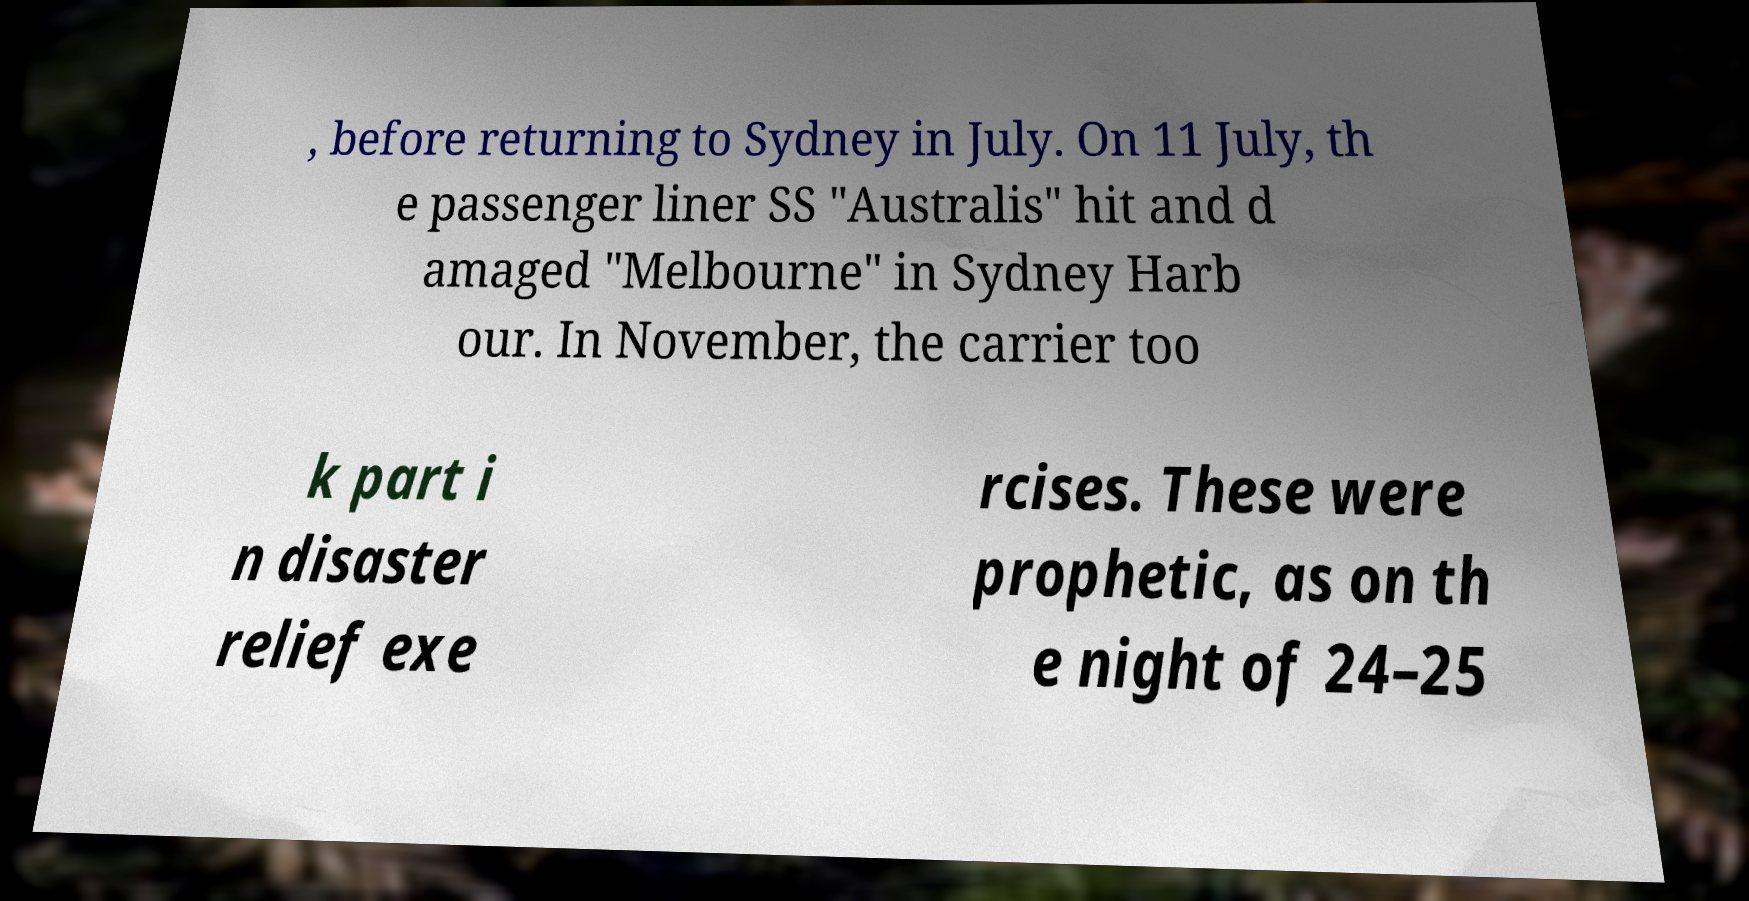There's text embedded in this image that I need extracted. Can you transcribe it verbatim? , before returning to Sydney in July. On 11 July, th e passenger liner SS "Australis" hit and d amaged "Melbourne" in Sydney Harb our. In November, the carrier too k part i n disaster relief exe rcises. These were prophetic, as on th e night of 24–25 